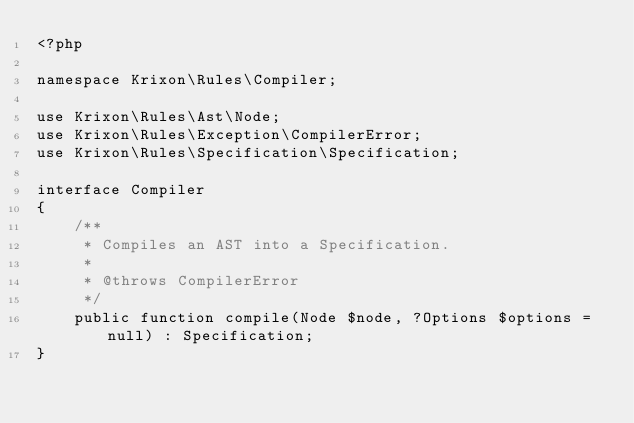<code> <loc_0><loc_0><loc_500><loc_500><_PHP_><?php

namespace Krixon\Rules\Compiler;

use Krixon\Rules\Ast\Node;
use Krixon\Rules\Exception\CompilerError;
use Krixon\Rules\Specification\Specification;

interface Compiler
{
    /**
     * Compiles an AST into a Specification.
     *
     * @throws CompilerError
     */
    public function compile(Node $node, ?Options $options = null) : Specification;
}</code> 